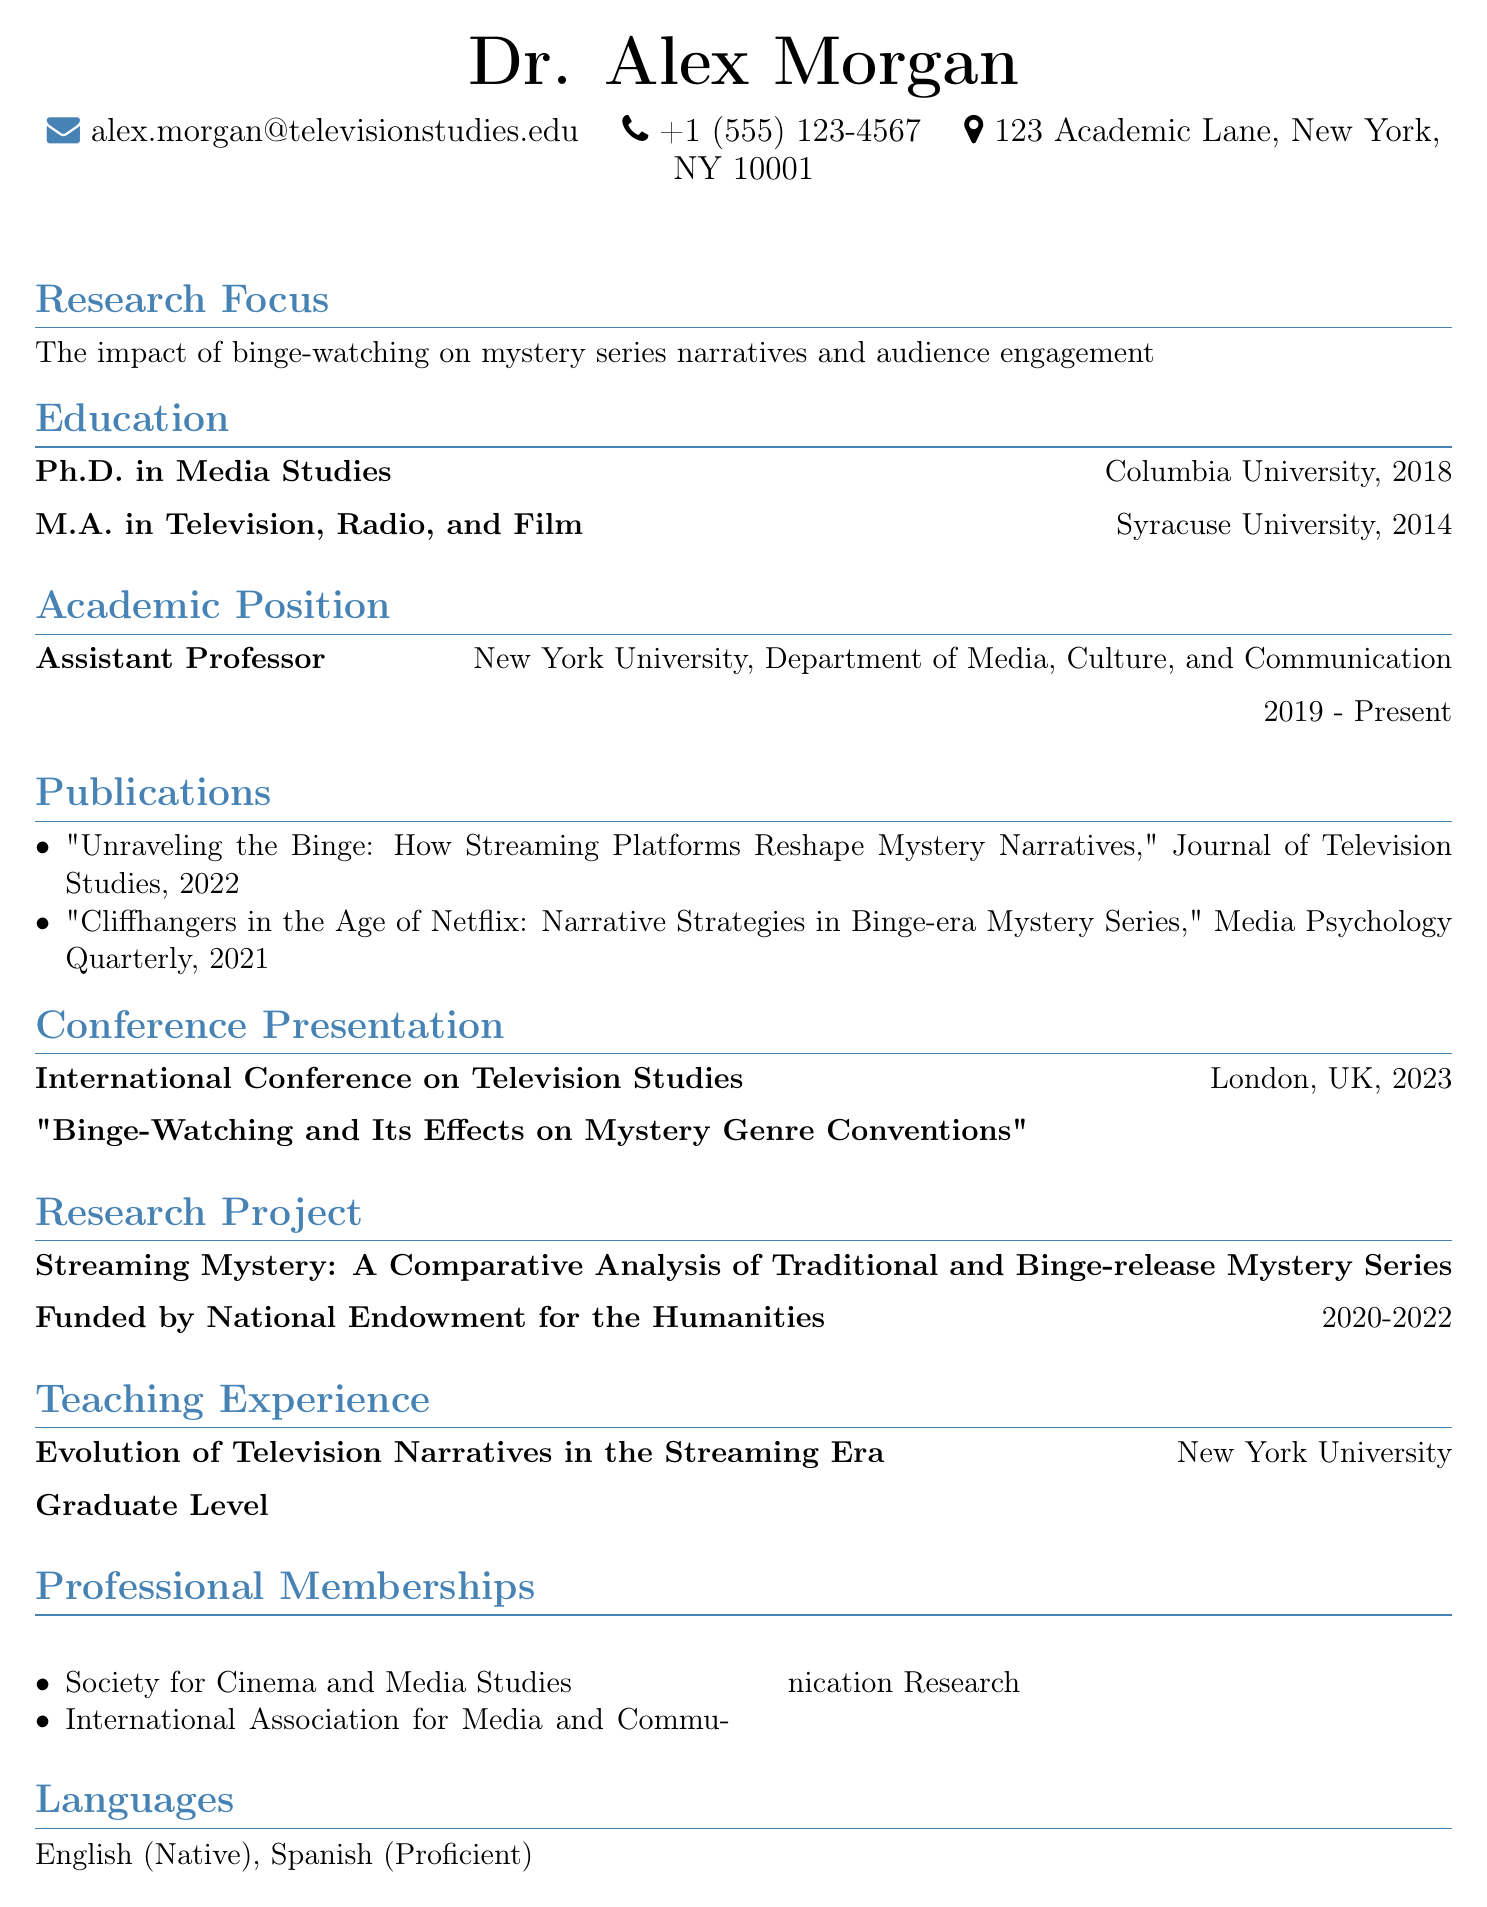What is the name of the person? The name of the person is at the top of the document, which states "Dr. Alex Morgan."
Answer: Dr. Alex Morgan What is Dr. Alex Morgan's email address? The email address is provided in the contact information section of the document, listed as "alex.morgan@televisionstudies.edu."
Answer: alex.morgan@televisionstudies.edu In which year did Dr. Morgan receive their Ph.D.? The year of receiving the Ph.D. is stated under the education section, specifically for Columbia University, which is "2018."
Answer: 2018 What is the title of the publication from 2022? The title is found in the publications section, specifically indicating the year 2022: "Unraveling the Binge: How Streaming Platforms Reshape Mystery Narratives."
Answer: Unraveling the Binge: How Streaming Platforms Reshape Mystery Narratives How long did the research project "Streaming Mystery" last? The duration of the research project is noted in the research project section, which states it lasted from "2020-2022."
Answer: 2020-2022 What is the main research focus of Dr. Morgan? The main research focus is explicitly stated in the research focus section, which mentions "The impact of binge-watching on mystery series narratives and audience engagement."
Answer: The impact of binge-watching on mystery series narratives and audience engagement What position does Dr. Morgan hold at New York University? The position is detailed in the academic positions section, where it states "Assistant Professor."
Answer: Assistant Professor How many languages does Dr. Morgan speak? The languages section lists the languages spoken, which are "English (Native)" and "Spanish (Proficient)," totaling two.
Answer: 2 Where did Dr. Morgan present at the conference in 2023? The presentation location is specified in the conference presentation section, stating it was in "London, UK."
Answer: London, UK 